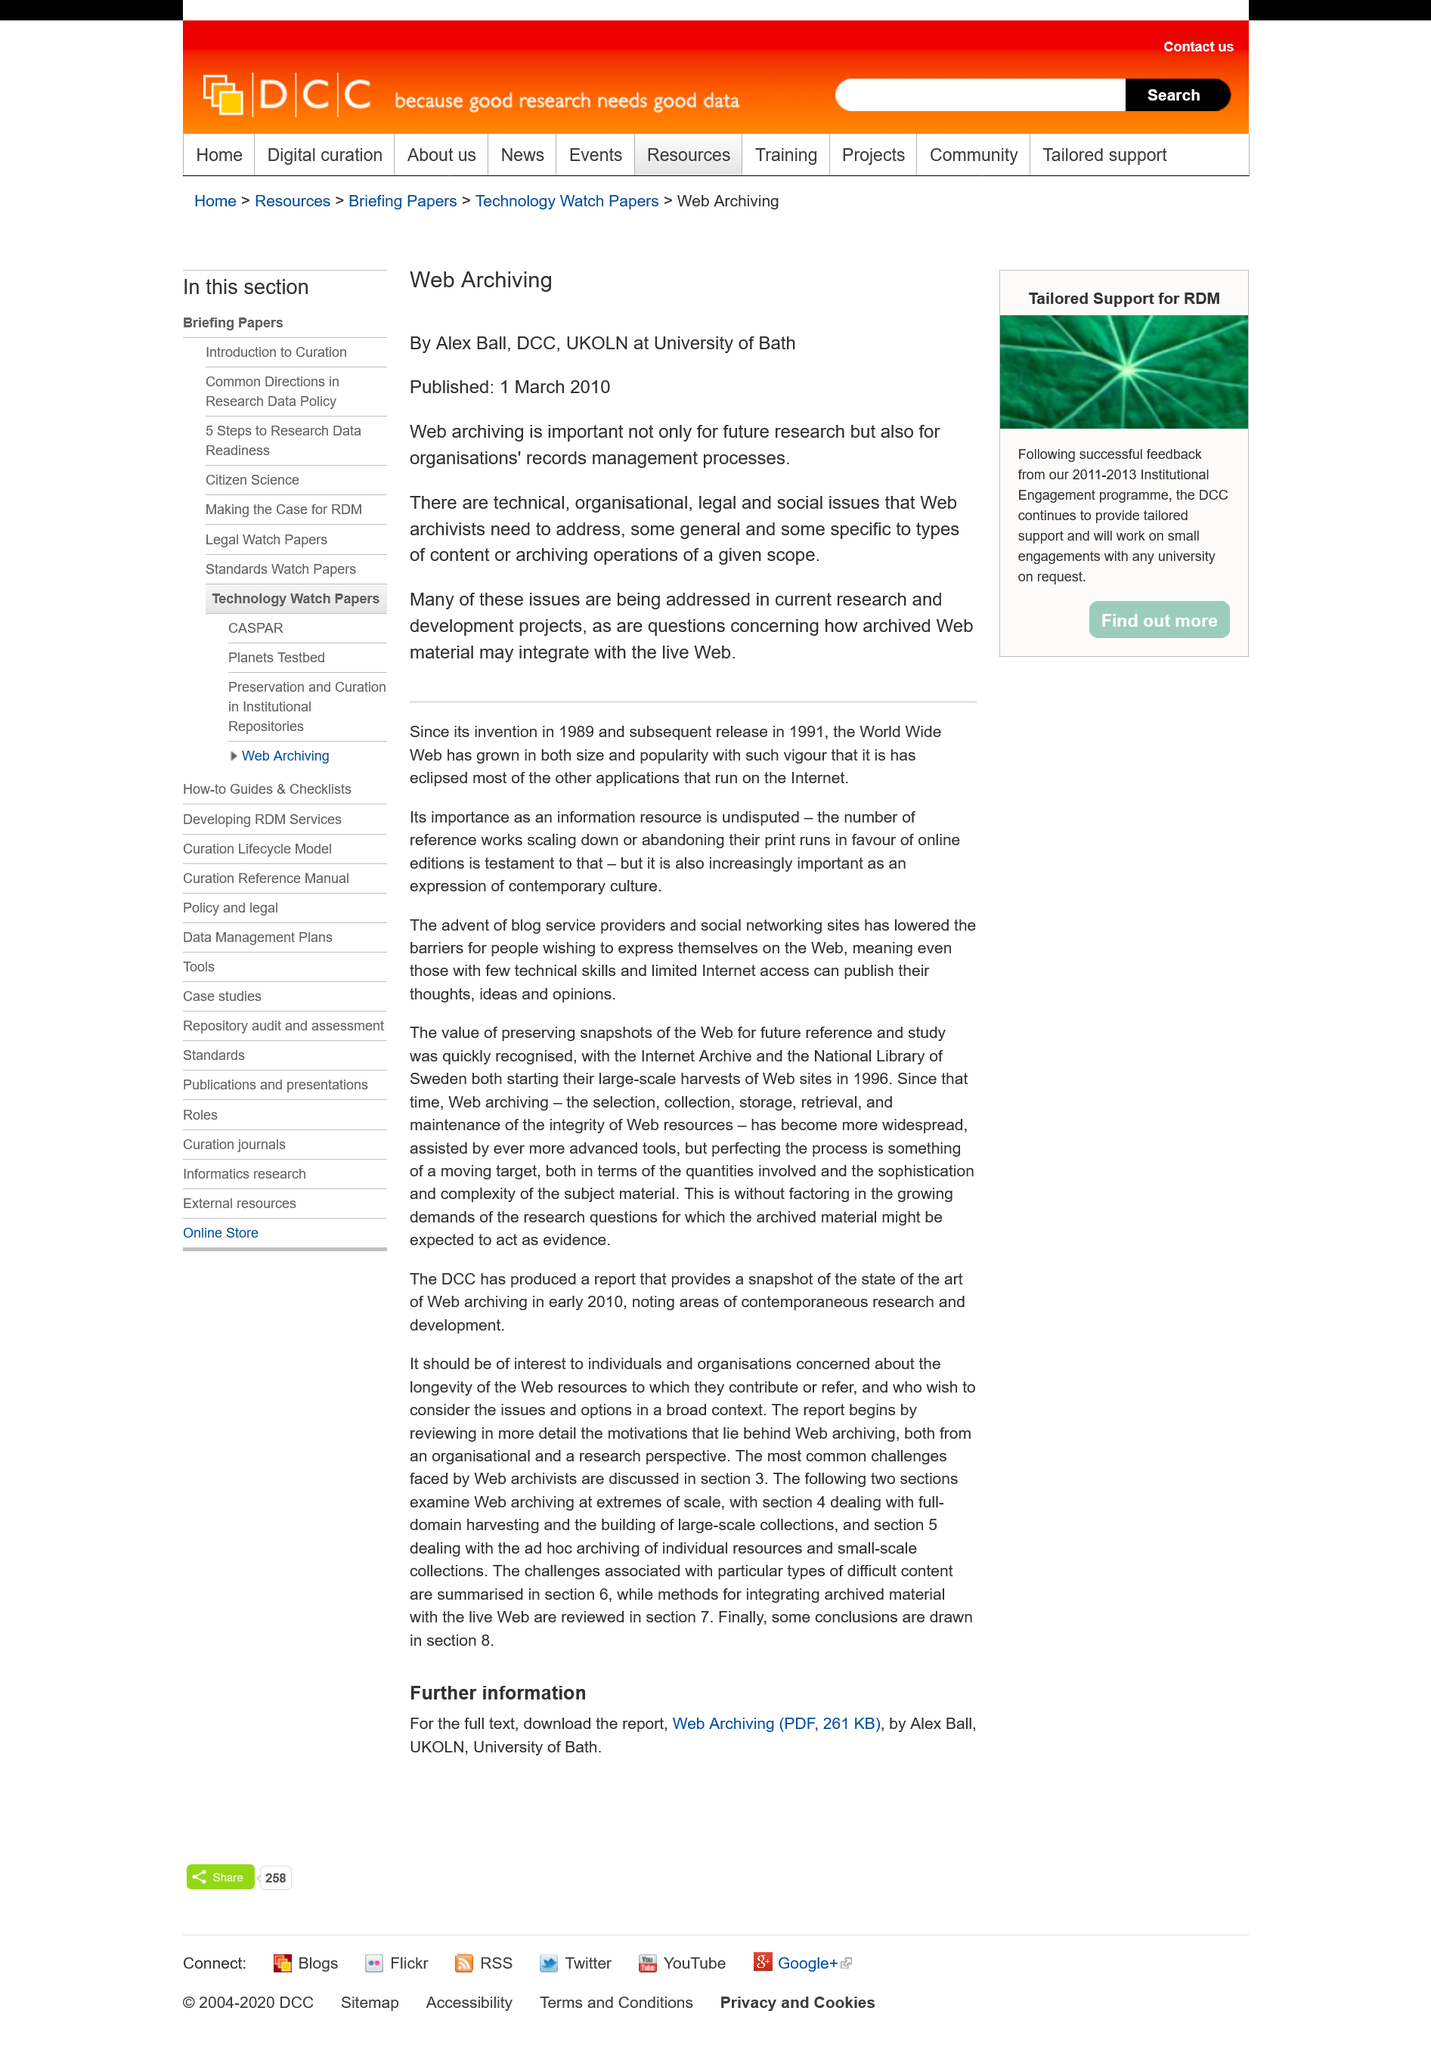Give some essential details in this illustration. Web archivists must address technical, organizational, legal, and social issues to effectively preserve the web for future generations. Web archiving is important because it is crucial not only for future research but also for organizations' records management processes. Alex Ball is employed by the University of Bath. 